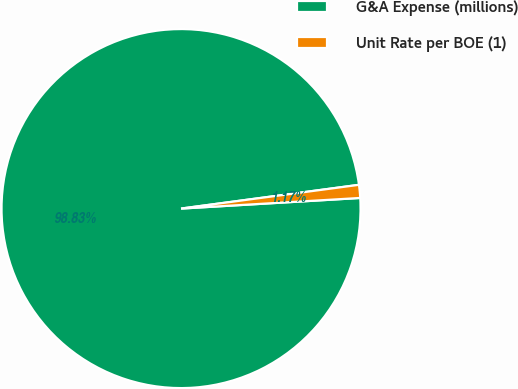Convert chart to OTSL. <chart><loc_0><loc_0><loc_500><loc_500><pie_chart><fcel>G&A Expense (millions)<fcel>Unit Rate per BOE (1)<nl><fcel>98.83%<fcel>1.17%<nl></chart> 